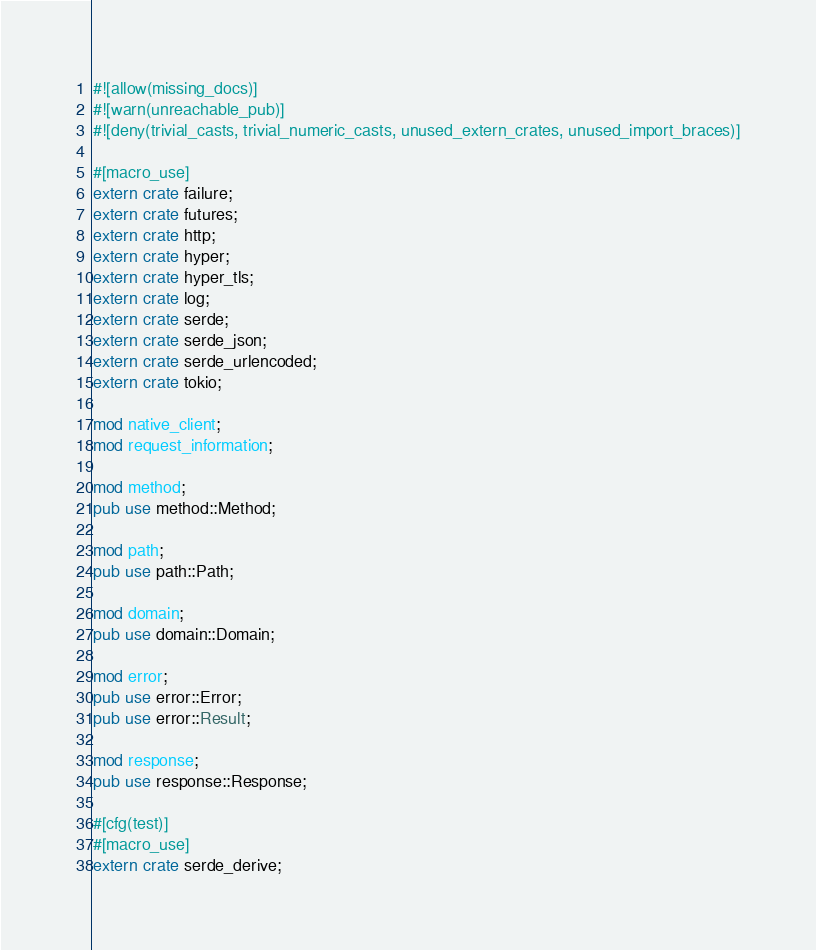<code> <loc_0><loc_0><loc_500><loc_500><_Rust_>#![allow(missing_docs)]
#![warn(unreachable_pub)]
#![deny(trivial_casts, trivial_numeric_casts, unused_extern_crates, unused_import_braces)]

#[macro_use]
extern crate failure;
extern crate futures;
extern crate http;
extern crate hyper;
extern crate hyper_tls;
extern crate log;
extern crate serde;
extern crate serde_json;
extern crate serde_urlencoded;
extern crate tokio;

mod native_client;
mod request_information;

mod method;
pub use method::Method;

mod path;
pub use path::Path;

mod domain;
pub use domain::Domain;

mod error;
pub use error::Error;
pub use error::Result;

mod response;
pub use response::Response;

#[cfg(test)]
#[macro_use]
extern crate serde_derive;
</code> 